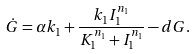Convert formula to latex. <formula><loc_0><loc_0><loc_500><loc_500>\dot { G } = \alpha k _ { 1 } + \frac { k _ { 1 } I _ { 1 } ^ { n _ { 1 } } } { K _ { 1 } ^ { n _ { 1 } } + I _ { 1 } ^ { n _ { 1 } } } - d G .</formula> 